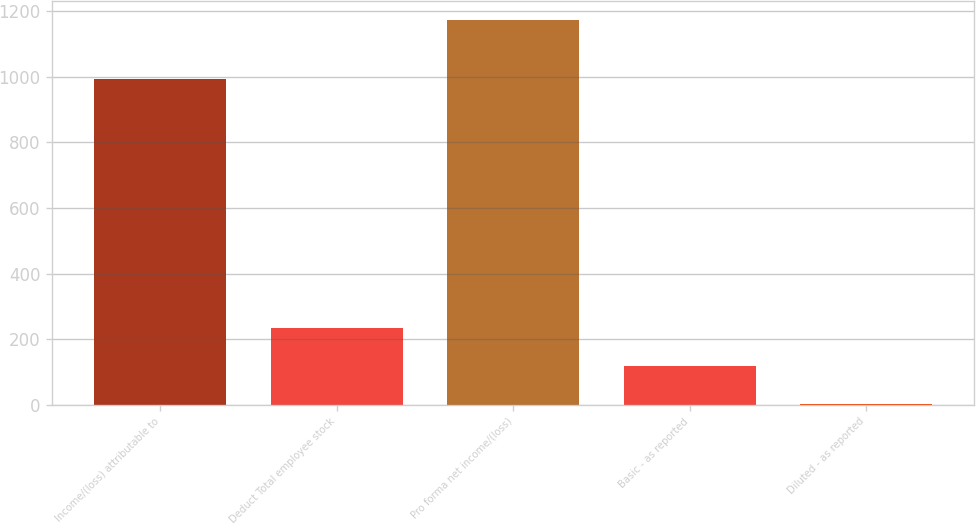Convert chart. <chart><loc_0><loc_0><loc_500><loc_500><bar_chart><fcel>Income/(loss) attributable to<fcel>Deduct Total employee stock<fcel>Pro forma net income/(loss)<fcel>Basic - as reported<fcel>Diluted - as reported<nl><fcel>995<fcel>235.24<fcel>1174<fcel>117.89<fcel>0.54<nl></chart> 